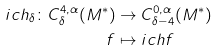Convert formula to latex. <formula><loc_0><loc_0><loc_500><loc_500>\L i c h _ { \delta } \colon C ^ { 4 , \alpha } _ { \delta } ( M ^ { * } ) & \rightarrow C ^ { 0 , \alpha } _ { \delta - 4 } ( M ^ { * } ) \\ f & \mapsto \L i c h f</formula> 